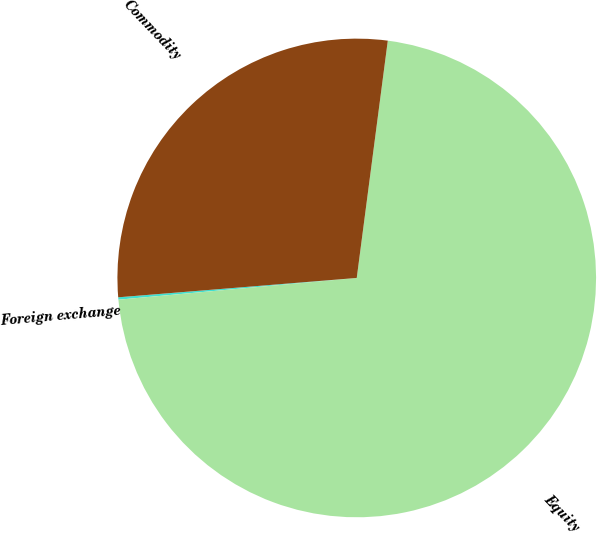Convert chart. <chart><loc_0><loc_0><loc_500><loc_500><pie_chart><fcel>Foreign exchange<fcel>Equity<fcel>Commodity<nl><fcel>0.16%<fcel>71.48%<fcel>28.36%<nl></chart> 